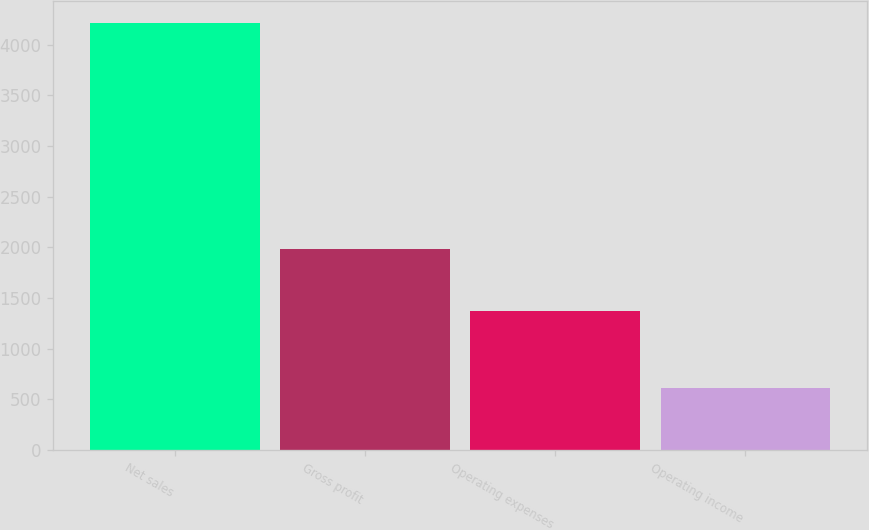Convert chart. <chart><loc_0><loc_0><loc_500><loc_500><bar_chart><fcel>Net sales<fcel>Gross profit<fcel>Operating expenses<fcel>Operating income<nl><fcel>4218<fcel>1981<fcel>1371<fcel>610<nl></chart> 